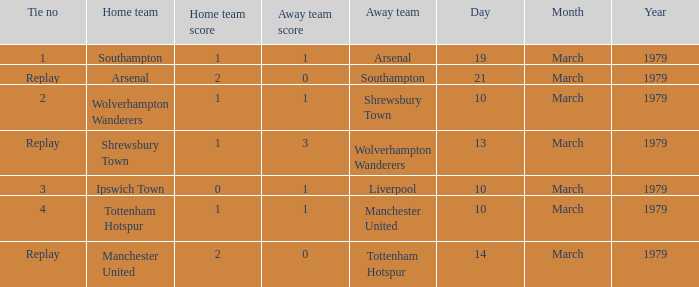What was the score for the tie that had Shrewsbury Town as home team? 1–3. 